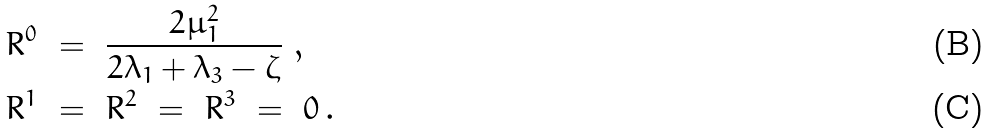<formula> <loc_0><loc_0><loc_500><loc_500>& R ^ { 0 } \ = \ \frac { 2 \mu _ { 1 } ^ { 2 } } { 2 \lambda _ { 1 } + \lambda _ { 3 } - \zeta } \ , \\ & R ^ { 1 } \ = \ R ^ { 2 } \ = \ R ^ { 3 } \ = \ 0 \, .</formula> 